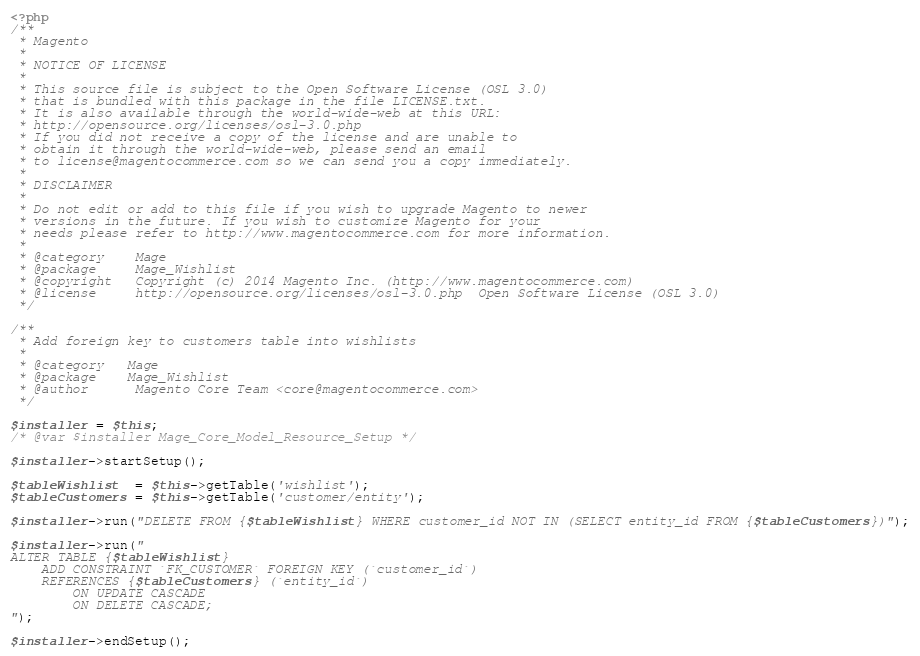Convert code to text. <code><loc_0><loc_0><loc_500><loc_500><_PHP_><?php
/**
 * Magento
 *
 * NOTICE OF LICENSE
 *
 * This source file is subject to the Open Software License (OSL 3.0)
 * that is bundled with this package in the file LICENSE.txt.
 * It is also available through the world-wide-web at this URL:
 * http://opensource.org/licenses/osl-3.0.php
 * If you did not receive a copy of the license and are unable to
 * obtain it through the world-wide-web, please send an email
 * to license@magentocommerce.com so we can send you a copy immediately.
 *
 * DISCLAIMER
 *
 * Do not edit or add to this file if you wish to upgrade Magento to newer
 * versions in the future. If you wish to customize Magento for your
 * needs please refer to http://www.magentocommerce.com for more information.
 *
 * @category    Mage
 * @package     Mage_Wishlist
 * @copyright   Copyright (c) 2014 Magento Inc. (http://www.magentocommerce.com)
 * @license     http://opensource.org/licenses/osl-3.0.php  Open Software License (OSL 3.0)
 */

/**
 * Add foreign key to customers table into wishlists
 *
 * @category   Mage
 * @package    Mage_Wishlist
 * @author      Magento Core Team <core@magentocommerce.com>
 */

$installer = $this;
/* @var $installer Mage_Core_Model_Resource_Setup */

$installer->startSetup();

$tableWishlist  = $this->getTable('wishlist');
$tableCustomers = $this->getTable('customer/entity');

$installer->run("DELETE FROM {$tableWishlist} WHERE customer_id NOT IN (SELECT entity_id FROM {$tableCustomers})");

$installer->run("
ALTER TABLE {$tableWishlist}
    ADD CONSTRAINT `FK_CUSTOMER` FOREIGN KEY (`customer_id`)
    REFERENCES {$tableCustomers} (`entity_id`)
        ON UPDATE CASCADE
        ON DELETE CASCADE;
");

$installer->endSetup();
</code> 